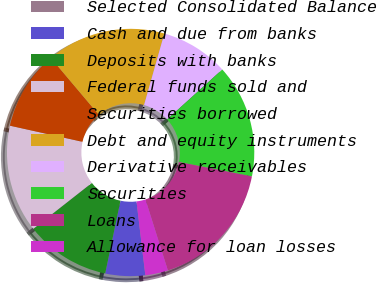Convert chart to OTSL. <chart><loc_0><loc_0><loc_500><loc_500><pie_chart><fcel>Selected Consolidated Balance<fcel>Cash and due from banks<fcel>Deposits with banks<fcel>Federal funds sold and<fcel>Securities borrowed<fcel>Debt and equity instruments<fcel>Derivative receivables<fcel>Securities<fcel>Loans<fcel>Allowance for loan losses<nl><fcel>0.01%<fcel>5.19%<fcel>11.11%<fcel>14.07%<fcel>10.37%<fcel>15.55%<fcel>8.89%<fcel>14.81%<fcel>17.03%<fcel>2.97%<nl></chart> 